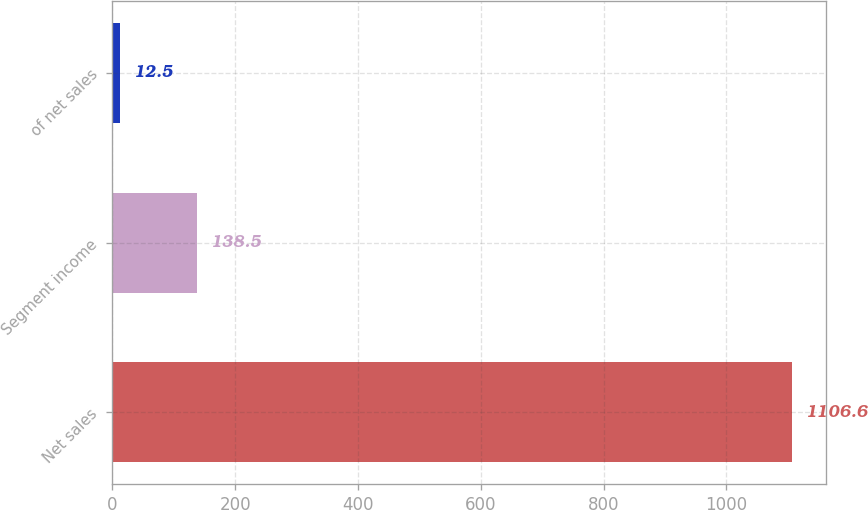Convert chart. <chart><loc_0><loc_0><loc_500><loc_500><bar_chart><fcel>Net sales<fcel>Segment income<fcel>of net sales<nl><fcel>1106.6<fcel>138.5<fcel>12.5<nl></chart> 